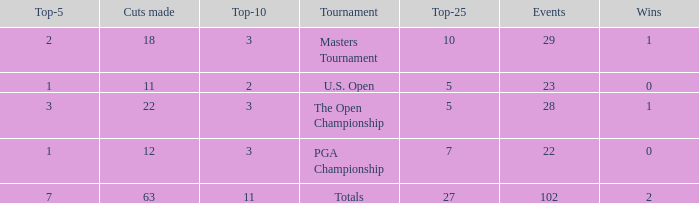How many top 10s connected with 3 top 5s and below 22 cuts made? None. Can you give me this table as a dict? {'header': ['Top-5', 'Cuts made', 'Top-10', 'Tournament', 'Top-25', 'Events', 'Wins'], 'rows': [['2', '18', '3', 'Masters Tournament', '10', '29', '1'], ['1', '11', '2', 'U.S. Open', '5', '23', '0'], ['3', '22', '3', 'The Open Championship', '5', '28', '1'], ['1', '12', '3', 'PGA Championship', '7', '22', '0'], ['7', '63', '11', 'Totals', '27', '102', '2']]} 